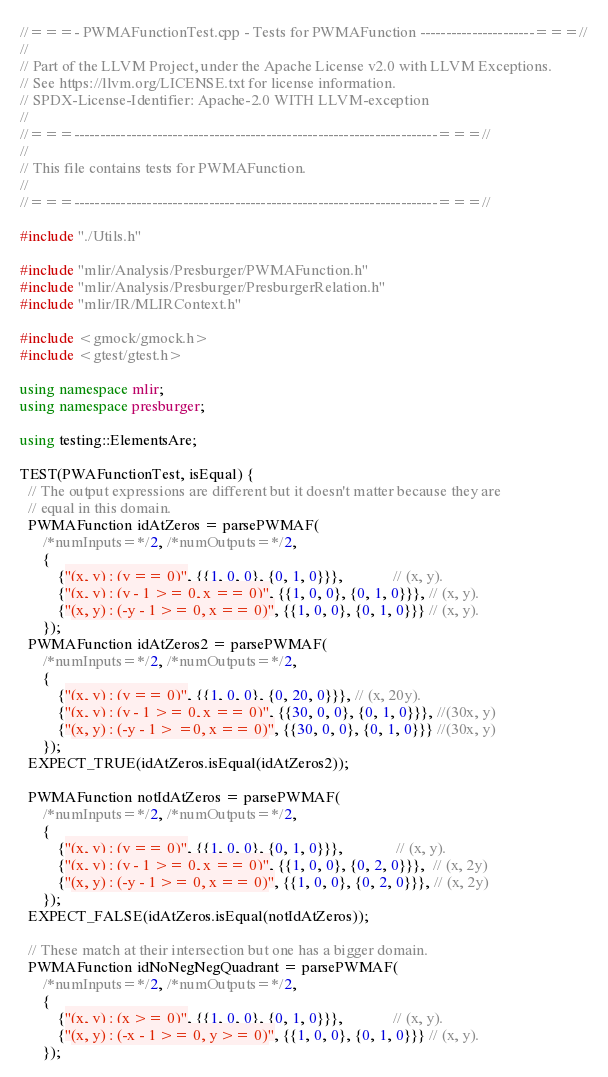Convert code to text. <code><loc_0><loc_0><loc_500><loc_500><_C++_>//===- PWMAFunctionTest.cpp - Tests for PWMAFunction ----------------------===//
//
// Part of the LLVM Project, under the Apache License v2.0 with LLVM Exceptions.
// See https://llvm.org/LICENSE.txt for license information.
// SPDX-License-Identifier: Apache-2.0 WITH LLVM-exception
//
//===----------------------------------------------------------------------===//
//
// This file contains tests for PWMAFunction.
//
//===----------------------------------------------------------------------===//

#include "./Utils.h"

#include "mlir/Analysis/Presburger/PWMAFunction.h"
#include "mlir/Analysis/Presburger/PresburgerRelation.h"
#include "mlir/IR/MLIRContext.h"

#include <gmock/gmock.h>
#include <gtest/gtest.h>

using namespace mlir;
using namespace presburger;

using testing::ElementsAre;

TEST(PWAFunctionTest, isEqual) {
  // The output expressions are different but it doesn't matter because they are
  // equal in this domain.
  PWMAFunction idAtZeros = parsePWMAF(
      /*numInputs=*/2, /*numOutputs=*/2,
      {
          {"(x, y) : (y == 0)", {{1, 0, 0}, {0, 1, 0}}},             // (x, y).
          {"(x, y) : (y - 1 >= 0, x == 0)", {{1, 0, 0}, {0, 1, 0}}}, // (x, y).
          {"(x, y) : (-y - 1 >= 0, x == 0)", {{1, 0, 0}, {0, 1, 0}}} // (x, y).
      });
  PWMAFunction idAtZeros2 = parsePWMAF(
      /*numInputs=*/2, /*numOutputs=*/2,
      {
          {"(x, y) : (y == 0)", {{1, 0, 0}, {0, 20, 0}}}, // (x, 20y).
          {"(x, y) : (y - 1 >= 0, x == 0)", {{30, 0, 0}, {0, 1, 0}}}, //(30x, y)
          {"(x, y) : (-y - 1 > =0, x == 0)", {{30, 0, 0}, {0, 1, 0}}} //(30x, y)
      });
  EXPECT_TRUE(idAtZeros.isEqual(idAtZeros2));

  PWMAFunction notIdAtZeros = parsePWMAF(
      /*numInputs=*/2, /*numOutputs=*/2,
      {
          {"(x, y) : (y == 0)", {{1, 0, 0}, {0, 1, 0}}},              // (x, y).
          {"(x, y) : (y - 1 >= 0, x == 0)", {{1, 0, 0}, {0, 2, 0}}},  // (x, 2y)
          {"(x, y) : (-y - 1 >= 0, x == 0)", {{1, 0, 0}, {0, 2, 0}}}, // (x, 2y)
      });
  EXPECT_FALSE(idAtZeros.isEqual(notIdAtZeros));

  // These match at their intersection but one has a bigger domain.
  PWMAFunction idNoNegNegQuadrant = parsePWMAF(
      /*numInputs=*/2, /*numOutputs=*/2,
      {
          {"(x, y) : (x >= 0)", {{1, 0, 0}, {0, 1, 0}}},             // (x, y).
          {"(x, y) : (-x - 1 >= 0, y >= 0)", {{1, 0, 0}, {0, 1, 0}}} // (x, y).
      });</code> 